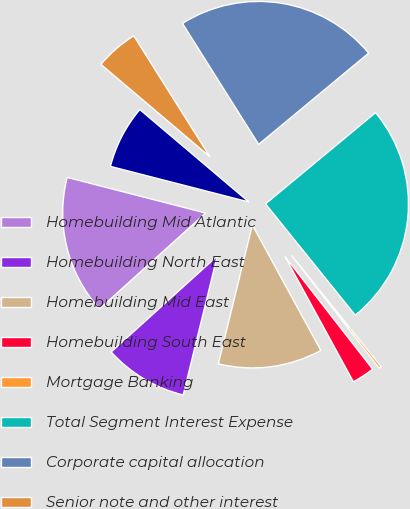Convert chart to OTSL. <chart><loc_0><loc_0><loc_500><loc_500><pie_chart><fcel>Homebuilding Mid Atlantic<fcel>Homebuilding North East<fcel>Homebuilding Mid East<fcel>Homebuilding South East<fcel>Mortgage Banking<fcel>Total Segment Interest Expense<fcel>Corporate capital allocation<fcel>Senior note and other interest<fcel>Consolidated Interest Expense<nl><fcel>15.7%<fcel>9.48%<fcel>11.78%<fcel>2.57%<fcel>0.27%<fcel>25.22%<fcel>22.92%<fcel>4.87%<fcel>7.18%<nl></chart> 